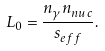<formula> <loc_0><loc_0><loc_500><loc_500>L _ { 0 } = \frac { n _ { \gamma } n _ { n u c } } { s _ { e f f } } .</formula> 